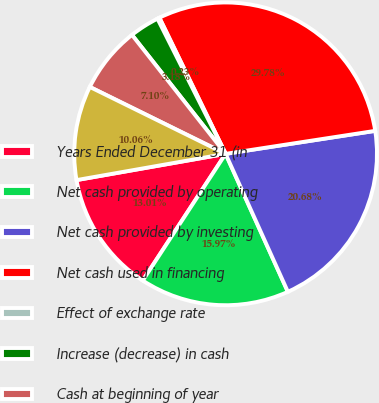<chart> <loc_0><loc_0><loc_500><loc_500><pie_chart><fcel>Years Ended December 31 (in<fcel>Net cash provided by operating<fcel>Net cash provided by investing<fcel>Net cash used in financing<fcel>Effect of exchange rate<fcel>Increase (decrease) in cash<fcel>Cash at beginning of year<fcel>Cash at end of year<nl><fcel>13.01%<fcel>15.97%<fcel>20.68%<fcel>29.78%<fcel>0.23%<fcel>3.18%<fcel>7.1%<fcel>10.06%<nl></chart> 